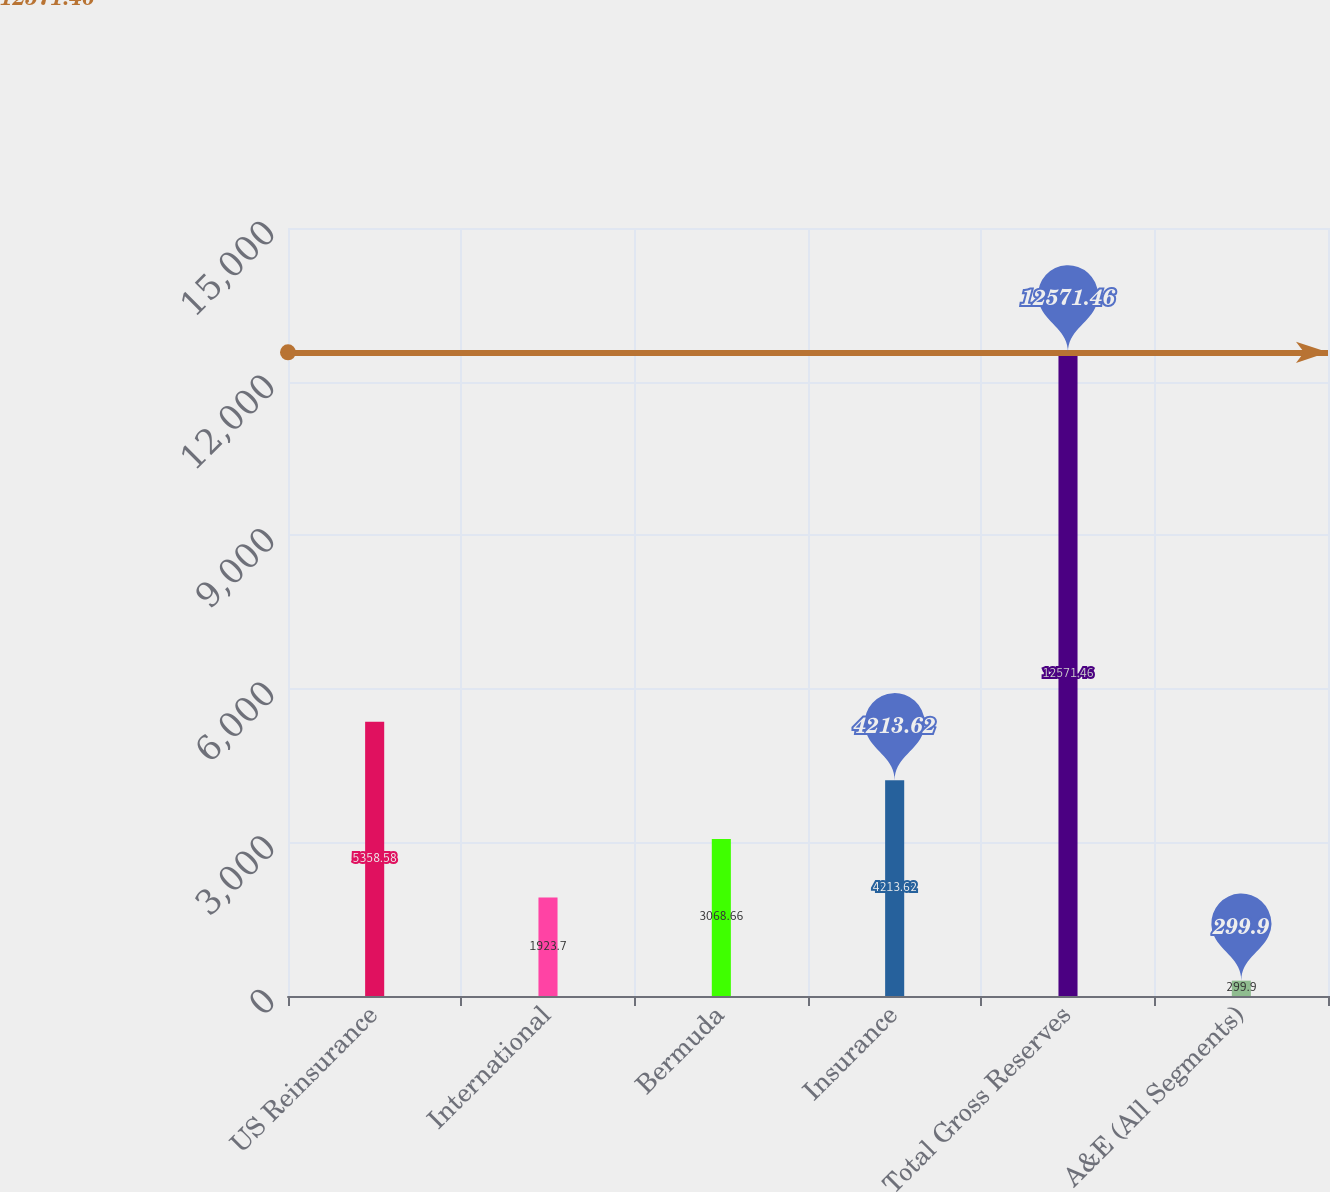Convert chart to OTSL. <chart><loc_0><loc_0><loc_500><loc_500><bar_chart><fcel>US Reinsurance<fcel>International<fcel>Bermuda<fcel>Insurance<fcel>Total Gross Reserves<fcel>A&E (All Segments)<nl><fcel>5358.58<fcel>1923.7<fcel>3068.66<fcel>4213.62<fcel>12571.5<fcel>299.9<nl></chart> 